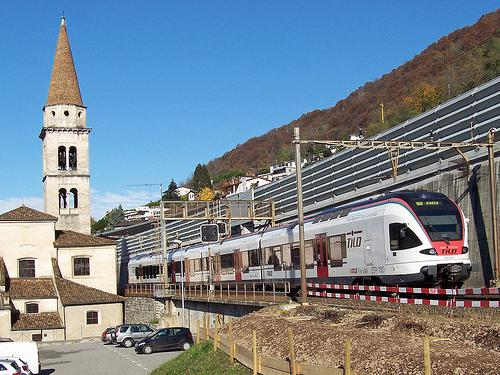Provide a poetic description of the general scenery. Under the vast blue heavens, a vintage red and white train rests beside a quaint white church, amidst parked cars and a palette of green and brown trees. Describe the environment of the scene. A sunny day with blue sky, white clouds, and a church with a brown roof, a train on tracks, and cars parked in a lot. Describe the setting of the image in a casual tone. It's a lovely day, and there's a cool train next to a charming white church, with some cars parked nearby and trees in the background. What are some of the details seen on the train? A red stripe, a logo on the side, numerous windows, and a black top are some of the visible details on the train. Mention the main mode of transportation visible in the image. The main mode of transportation visible in the image is the red and white train on the tracks. Provide a brief description of the most prominent objects in the image. A red and white train on tracks, a white church with a brown steeple, various cars parked nearby, and green/brown trees in the distance. Summarize the image content in a single sentence. A train stationed beside a church and alongside parked cars set against a backdrop of trees and a blue sky with clouds. What type of building is prominently featured in the image? A white church with a brown steeple and tan walls is prominently featured in the image. What is the condition of the sky in the image. The sky is blue with some white clouds scattered across it. Identify the primary colors seen in the image. Primary colors seen are red, white, blue, green, brown, and black. 